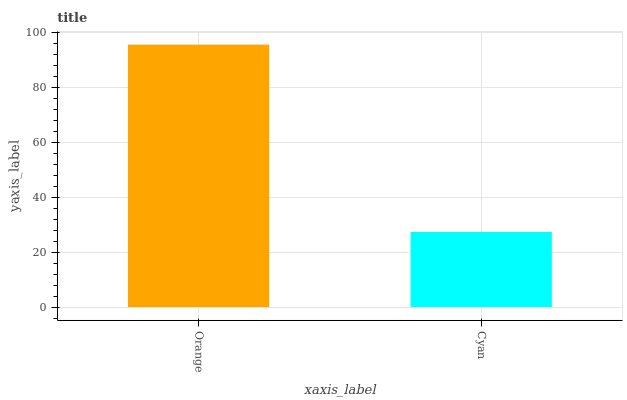Is Cyan the maximum?
Answer yes or no. No. Is Orange greater than Cyan?
Answer yes or no. Yes. Is Cyan less than Orange?
Answer yes or no. Yes. Is Cyan greater than Orange?
Answer yes or no. No. Is Orange less than Cyan?
Answer yes or no. No. Is Orange the high median?
Answer yes or no. Yes. Is Cyan the low median?
Answer yes or no. Yes. Is Cyan the high median?
Answer yes or no. No. Is Orange the low median?
Answer yes or no. No. 